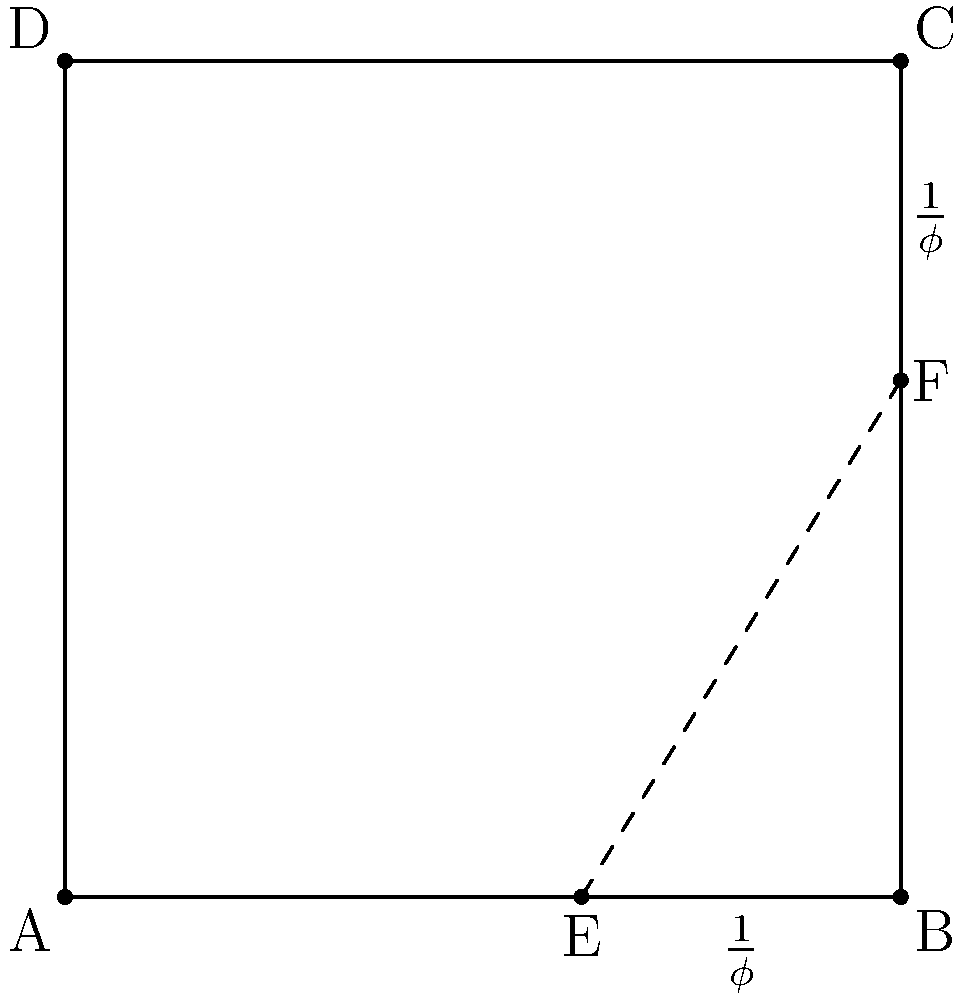In this composition, a rectangle ABCD is divided by a line EF according to the golden ratio. If the length of AB is 1 unit, what is the length of EF to the nearest hundredth? To find the length of EF, we can follow these steps:

1. Recognize that AE:EB follows the golden ratio, which is approximately 1:1.618 or 1:$\phi$.

2. Given that AB = 1, we can deduce:
   AE = $\frac{1}{\phi}$ and EB = $\frac{1}{\phi^2}$

3. In the right triangle AEF:
   - AE = $\frac{1}{\phi}$
   - AF = $\frac{1}{\phi}$ (since CF:FC also follows the golden ratio)

4. We can use the Pythagorean theorem to find EF:
   $EF^2 = AE^2 + AF^2$

5. Substitute the values:
   $EF^2 = (\frac{1}{\phi})^2 + (\frac{1}{\phi})^2 = \frac{2}{\phi^2}$

6. Simplify:
   $EF = \sqrt{\frac{2}{\phi^2}} = \frac{\sqrt{2}}{\phi}$

7. Calculate the value:
   $\phi = \frac{1 + \sqrt{5}}{2} \approx 1.618$
   $EF = \frac{\sqrt{2}}{1.618} \approx 0.8744$

8. Rounding to the nearest hundredth:
   $EF \approx 0.87$
Answer: 0.87 